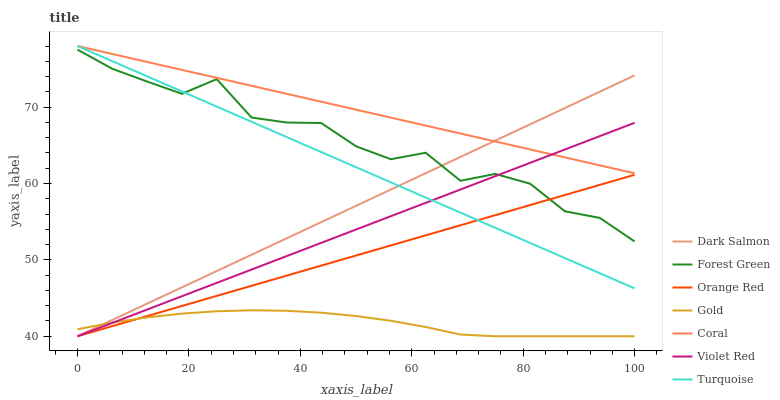Does Gold have the minimum area under the curve?
Answer yes or no. Yes. Does Coral have the maximum area under the curve?
Answer yes or no. Yes. Does Coral have the minimum area under the curve?
Answer yes or no. No. Does Gold have the maximum area under the curve?
Answer yes or no. No. Is Orange Red the smoothest?
Answer yes or no. Yes. Is Forest Green the roughest?
Answer yes or no. Yes. Is Gold the smoothest?
Answer yes or no. No. Is Gold the roughest?
Answer yes or no. No. Does Violet Red have the lowest value?
Answer yes or no. Yes. Does Coral have the lowest value?
Answer yes or no. No. Does Turquoise have the highest value?
Answer yes or no. Yes. Does Gold have the highest value?
Answer yes or no. No. Is Orange Red less than Coral?
Answer yes or no. Yes. Is Coral greater than Orange Red?
Answer yes or no. Yes. Does Turquoise intersect Dark Salmon?
Answer yes or no. Yes. Is Turquoise less than Dark Salmon?
Answer yes or no. No. Is Turquoise greater than Dark Salmon?
Answer yes or no. No. Does Orange Red intersect Coral?
Answer yes or no. No. 